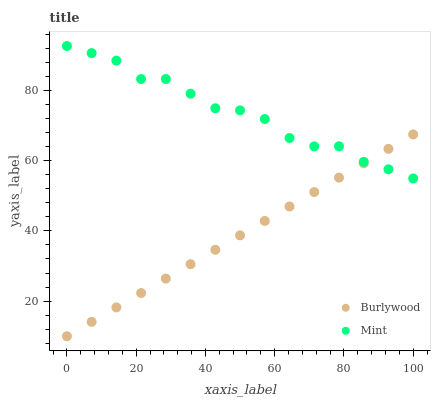Does Burlywood have the minimum area under the curve?
Answer yes or no. Yes. Does Mint have the maximum area under the curve?
Answer yes or no. Yes. Does Mint have the minimum area under the curve?
Answer yes or no. No. Is Burlywood the smoothest?
Answer yes or no. Yes. Is Mint the roughest?
Answer yes or no. Yes. Is Mint the smoothest?
Answer yes or no. No. Does Burlywood have the lowest value?
Answer yes or no. Yes. Does Mint have the lowest value?
Answer yes or no. No. Does Mint have the highest value?
Answer yes or no. Yes. Does Burlywood intersect Mint?
Answer yes or no. Yes. Is Burlywood less than Mint?
Answer yes or no. No. Is Burlywood greater than Mint?
Answer yes or no. No. 